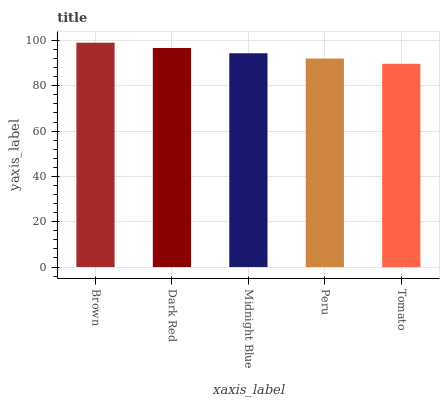Is Tomato the minimum?
Answer yes or no. Yes. Is Brown the maximum?
Answer yes or no. Yes. Is Dark Red the minimum?
Answer yes or no. No. Is Dark Red the maximum?
Answer yes or no. No. Is Brown greater than Dark Red?
Answer yes or no. Yes. Is Dark Red less than Brown?
Answer yes or no. Yes. Is Dark Red greater than Brown?
Answer yes or no. No. Is Brown less than Dark Red?
Answer yes or no. No. Is Midnight Blue the high median?
Answer yes or no. Yes. Is Midnight Blue the low median?
Answer yes or no. Yes. Is Brown the high median?
Answer yes or no. No. Is Brown the low median?
Answer yes or no. No. 